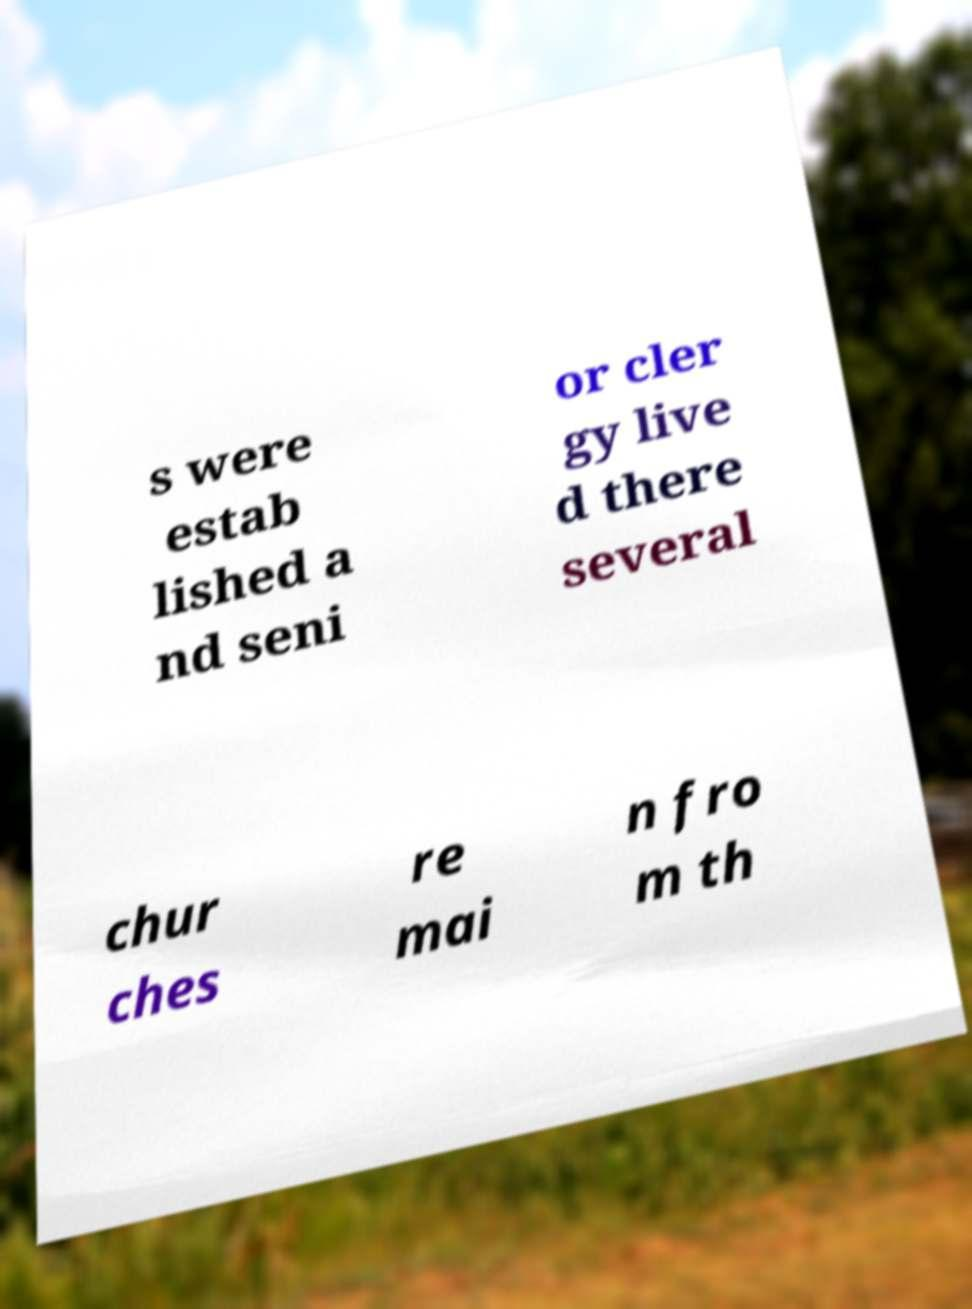Please identify and transcribe the text found in this image. s were estab lished a nd seni or cler gy live d there several chur ches re mai n fro m th 